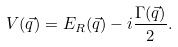Convert formula to latex. <formula><loc_0><loc_0><loc_500><loc_500>V ( \vec { q } ) = E _ { R } ( \vec { q } ) - i \frac { \Gamma ( \vec { q } ) } { 2 } .</formula> 